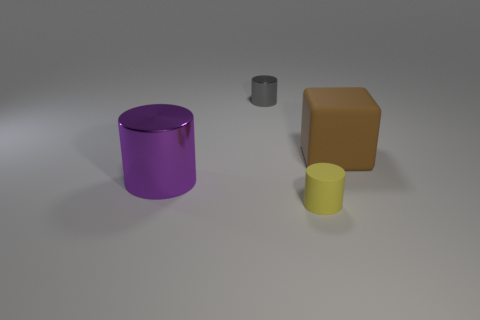Is there any other thing that is the same shape as the large brown thing?
Provide a short and direct response. No. What number of small gray things are behind the small object that is left of the tiny object that is in front of the tiny gray metal cylinder?
Give a very brief answer. 0. There is a big cube; does it have the same color as the small object behind the large brown rubber block?
Your answer should be compact. No. Are there more metal things that are in front of the cube than cylinders?
Your answer should be compact. No. How many things are either large things that are on the right side of the yellow thing or objects that are left of the brown cube?
Provide a short and direct response. 4. There is another thing that is made of the same material as the large brown thing; what size is it?
Your response must be concise. Small. There is a metal thing behind the large rubber cube; does it have the same shape as the big purple object?
Ensure brevity in your answer.  Yes. What number of purple objects are either tiny objects or cylinders?
Keep it short and to the point. 1. How many other things are the same shape as the small matte thing?
Provide a succinct answer. 2. What is the shape of the thing that is behind the big purple shiny cylinder and on the left side of the brown cube?
Your answer should be compact. Cylinder. 